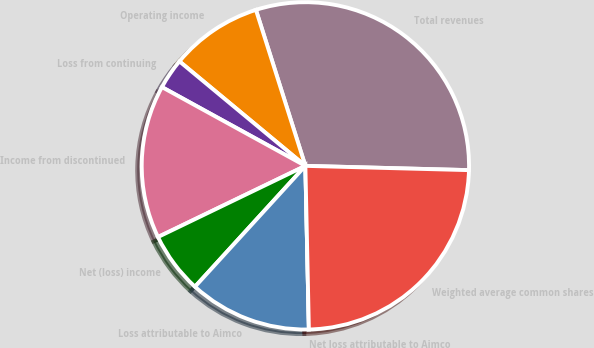<chart> <loc_0><loc_0><loc_500><loc_500><pie_chart><fcel>Total revenues<fcel>Operating income<fcel>Loss from continuing<fcel>Income from discontinued<fcel>Net (loss) income<fcel>Loss attributable to Aimco<fcel>Net loss attributable to Aimco<fcel>Weighted average common shares<nl><fcel>30.3%<fcel>9.09%<fcel>3.03%<fcel>15.15%<fcel>6.06%<fcel>12.12%<fcel>0.0%<fcel>24.24%<nl></chart> 